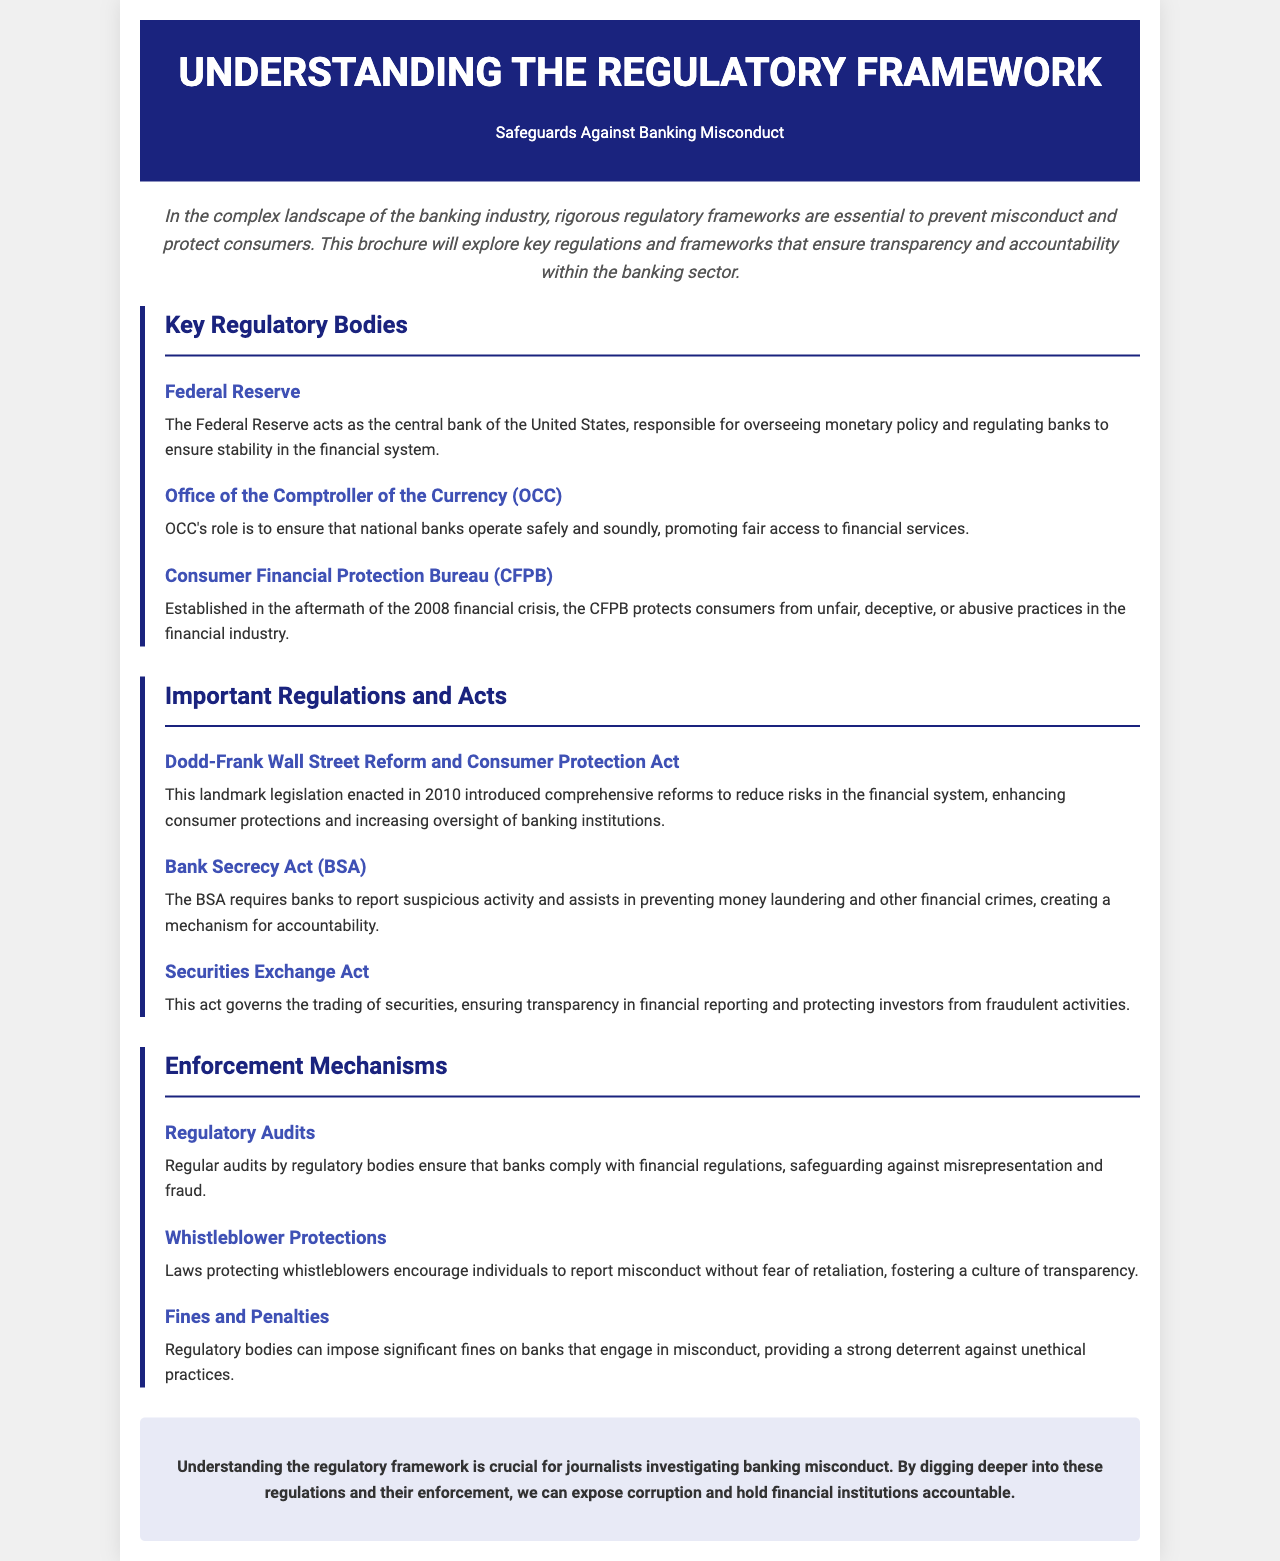What is the title of the brochure? The title is prominently displayed at the top of the brochure, identifying the main topic of focus.
Answer: Understanding the Regulatory Framework Who oversees monetary policy in the United States? This role is specifically assigned to a key regulatory body mentioned in the document.
Answer: Federal Reserve What act was enacted in 2010 to reform financial regulations? The brochure addresses this significant piece of legislation aimed at enhancing consumer protections.
Answer: Dodd-Frank Wall Street Reform and Consumer Protection Act What does the Bank Secrecy Act require from banks? The document explains the primary obligation imposed by this act to help in crime prevention.
Answer: Report suspicious activity Which regulatory body protects consumers from unfair practices? This organization was established in response to a financial crisis, as mentioned in the brochure.
Answer: Consumer Financial Protection Bureau What is one enforcement mechanism mentioned in the brochure? The document lists several methods to uphold banking regulations; one of them is highlighted here.
Answer: Regulatory Audits What can be imposed on banks that engage in misconduct? The brochure states consequences for unethical practices in the banking industry.
Answer: Fines What does the conclusion of the brochure emphasize? The final section of the document underscores the importance of understanding specific regulations and their implications.
Answer: Investigating banking misconduct 